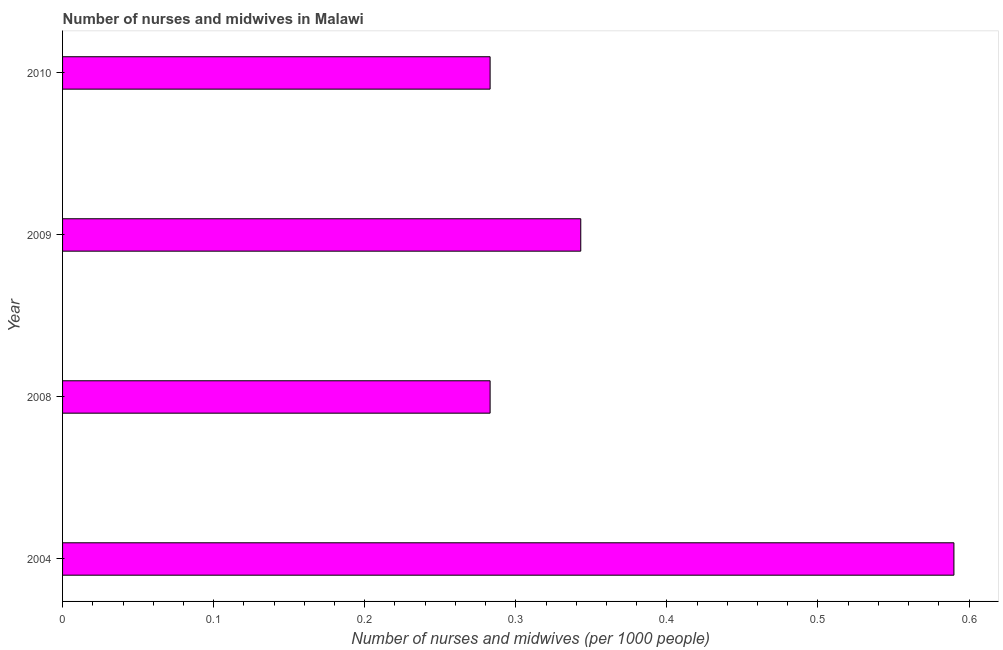Does the graph contain any zero values?
Make the answer very short. No. What is the title of the graph?
Ensure brevity in your answer.  Number of nurses and midwives in Malawi. What is the label or title of the X-axis?
Provide a short and direct response. Number of nurses and midwives (per 1000 people). What is the label or title of the Y-axis?
Offer a terse response. Year. What is the number of nurses and midwives in 2010?
Provide a short and direct response. 0.28. Across all years, what is the maximum number of nurses and midwives?
Provide a short and direct response. 0.59. Across all years, what is the minimum number of nurses and midwives?
Provide a short and direct response. 0.28. In which year was the number of nurses and midwives minimum?
Provide a succinct answer. 2008. What is the sum of the number of nurses and midwives?
Your answer should be compact. 1.5. What is the difference between the number of nurses and midwives in 2008 and 2009?
Your response must be concise. -0.06. What is the average number of nurses and midwives per year?
Ensure brevity in your answer.  0.38. What is the median number of nurses and midwives?
Give a very brief answer. 0.31. In how many years, is the number of nurses and midwives greater than 0.04 ?
Provide a short and direct response. 4. Do a majority of the years between 2009 and 2010 (inclusive) have number of nurses and midwives greater than 0.26 ?
Keep it short and to the point. Yes. What is the ratio of the number of nurses and midwives in 2009 to that in 2010?
Give a very brief answer. 1.21. Is the number of nurses and midwives in 2008 less than that in 2010?
Make the answer very short. No. Is the difference between the number of nurses and midwives in 2008 and 2010 greater than the difference between any two years?
Give a very brief answer. No. What is the difference between the highest and the second highest number of nurses and midwives?
Ensure brevity in your answer.  0.25. Is the sum of the number of nurses and midwives in 2004 and 2009 greater than the maximum number of nurses and midwives across all years?
Give a very brief answer. Yes. What is the difference between the highest and the lowest number of nurses and midwives?
Provide a short and direct response. 0.31. How many years are there in the graph?
Give a very brief answer. 4. Are the values on the major ticks of X-axis written in scientific E-notation?
Offer a very short reply. No. What is the Number of nurses and midwives (per 1000 people) in 2004?
Make the answer very short. 0.59. What is the Number of nurses and midwives (per 1000 people) of 2008?
Offer a terse response. 0.28. What is the Number of nurses and midwives (per 1000 people) of 2009?
Your answer should be compact. 0.34. What is the Number of nurses and midwives (per 1000 people) in 2010?
Give a very brief answer. 0.28. What is the difference between the Number of nurses and midwives (per 1000 people) in 2004 and 2008?
Your answer should be very brief. 0.31. What is the difference between the Number of nurses and midwives (per 1000 people) in 2004 and 2009?
Offer a very short reply. 0.25. What is the difference between the Number of nurses and midwives (per 1000 people) in 2004 and 2010?
Keep it short and to the point. 0.31. What is the difference between the Number of nurses and midwives (per 1000 people) in 2008 and 2009?
Offer a very short reply. -0.06. What is the difference between the Number of nurses and midwives (per 1000 people) in 2008 and 2010?
Keep it short and to the point. 0. What is the ratio of the Number of nurses and midwives (per 1000 people) in 2004 to that in 2008?
Make the answer very short. 2.08. What is the ratio of the Number of nurses and midwives (per 1000 people) in 2004 to that in 2009?
Your answer should be compact. 1.72. What is the ratio of the Number of nurses and midwives (per 1000 people) in 2004 to that in 2010?
Offer a terse response. 2.08. What is the ratio of the Number of nurses and midwives (per 1000 people) in 2008 to that in 2009?
Keep it short and to the point. 0.82. What is the ratio of the Number of nurses and midwives (per 1000 people) in 2009 to that in 2010?
Provide a short and direct response. 1.21. 